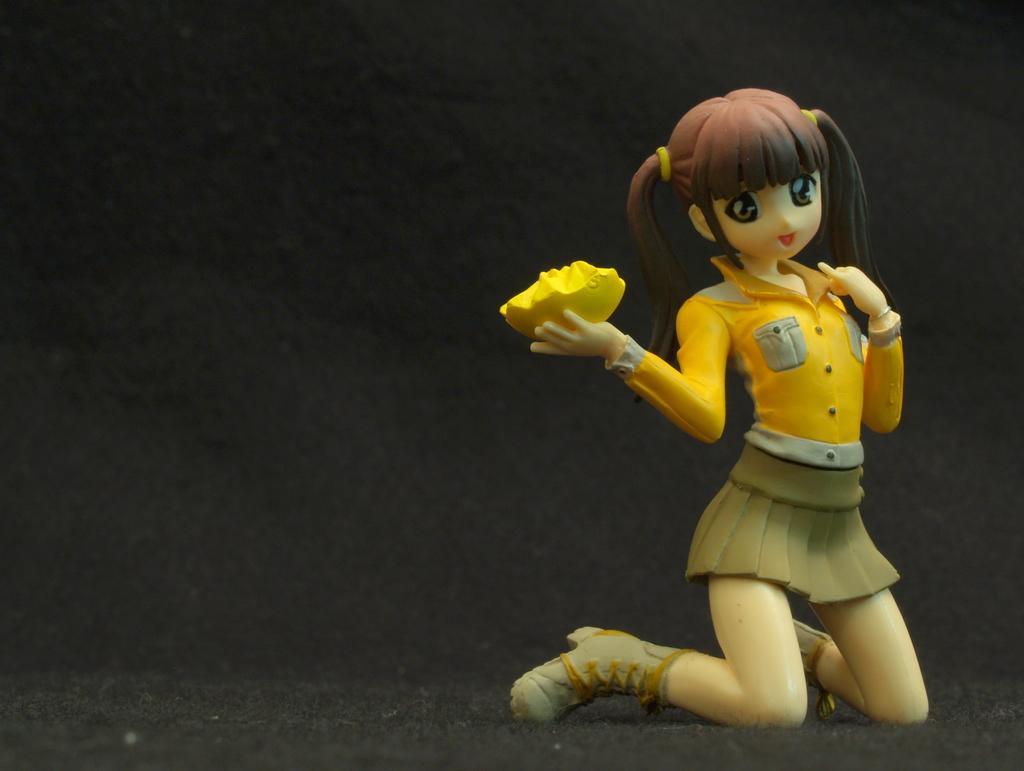Could you give a brief overview of what you see in this image? On the right side of this image there is a toy of a girl. There is a yellow color object in the hand. The background is dark. 